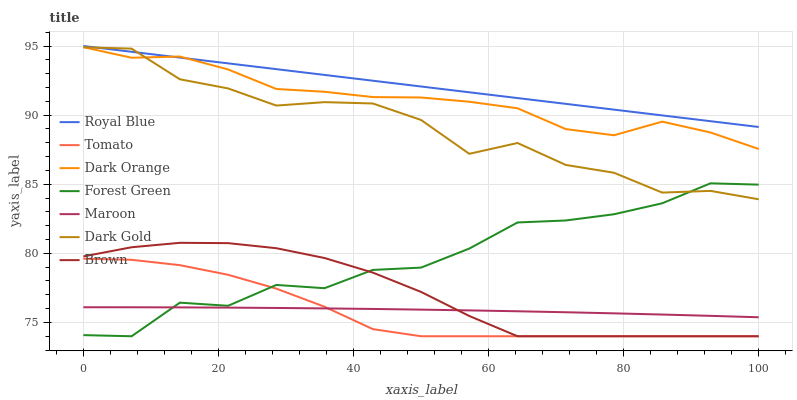Does Tomato have the minimum area under the curve?
Answer yes or no. Yes. Does Royal Blue have the maximum area under the curve?
Answer yes or no. Yes. Does Dark Orange have the minimum area under the curve?
Answer yes or no. No. Does Dark Orange have the maximum area under the curve?
Answer yes or no. No. Is Royal Blue the smoothest?
Answer yes or no. Yes. Is Dark Gold the roughest?
Answer yes or no. Yes. Is Dark Orange the smoothest?
Answer yes or no. No. Is Dark Orange the roughest?
Answer yes or no. No. Does Tomato have the lowest value?
Answer yes or no. Yes. Does Dark Orange have the lowest value?
Answer yes or no. No. Does Royal Blue have the highest value?
Answer yes or no. Yes. Does Dark Orange have the highest value?
Answer yes or no. No. Is Forest Green less than Royal Blue?
Answer yes or no. Yes. Is Dark Orange greater than Forest Green?
Answer yes or no. Yes. Does Royal Blue intersect Dark Orange?
Answer yes or no. Yes. Is Royal Blue less than Dark Orange?
Answer yes or no. No. Is Royal Blue greater than Dark Orange?
Answer yes or no. No. Does Forest Green intersect Royal Blue?
Answer yes or no. No. 